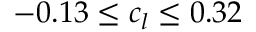<formula> <loc_0><loc_0><loc_500><loc_500>- 0 . 1 3 \leq c _ { l } \leq 0 . 3 2</formula> 